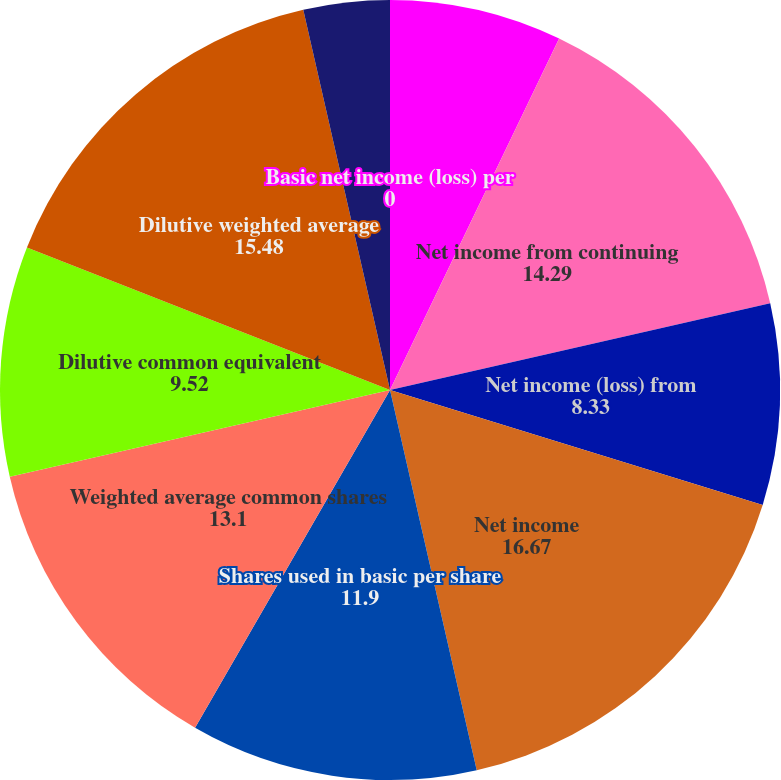Convert chart to OTSL. <chart><loc_0><loc_0><loc_500><loc_500><pie_chart><fcel>(In thousands except per share<fcel>Net income from continuing<fcel>Net income (loss) from<fcel>Net income<fcel>Shares used in basic per share<fcel>Weighted average common shares<fcel>Dilutive common equivalent<fcel>Dilutive weighted average<fcel>Basic net income per share<fcel>Basic net income (loss) per<nl><fcel>7.14%<fcel>14.29%<fcel>8.33%<fcel>16.67%<fcel>11.9%<fcel>13.1%<fcel>9.52%<fcel>15.48%<fcel>3.57%<fcel>0.0%<nl></chart> 